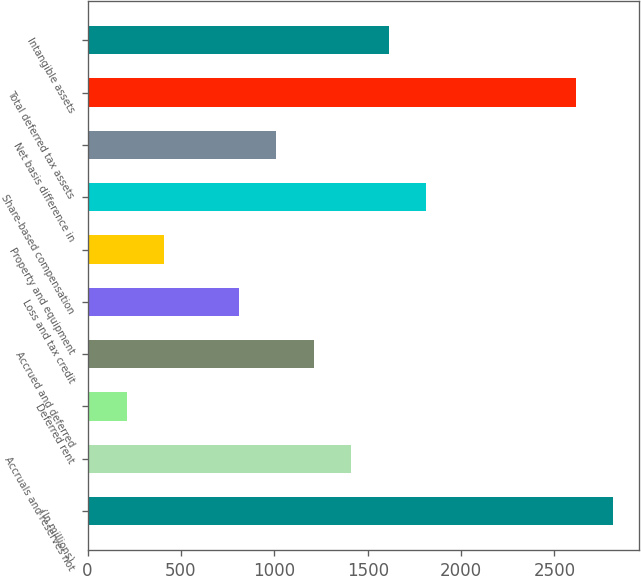<chart> <loc_0><loc_0><loc_500><loc_500><bar_chart><fcel>(In millions)<fcel>Accruals and reserves not<fcel>Deferred rent<fcel>Accrued and deferred<fcel>Loss and tax credit<fcel>Property and equipment<fcel>Share-based compensation<fcel>Net basis difference in<fcel>Total deferred tax assets<fcel>Intangible assets<nl><fcel>2814.2<fcel>1412.1<fcel>210.3<fcel>1211.8<fcel>811.2<fcel>410.6<fcel>1812.7<fcel>1011.5<fcel>2613.9<fcel>1612.4<nl></chart> 